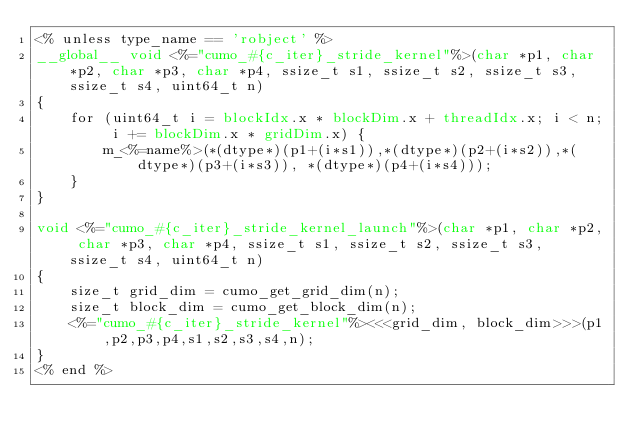Convert code to text. <code><loc_0><loc_0><loc_500><loc_500><_Cuda_><% unless type_name == 'robject' %>
__global__ void <%="cumo_#{c_iter}_stride_kernel"%>(char *p1, char *p2, char *p3, char *p4, ssize_t s1, ssize_t s2, ssize_t s3, ssize_t s4, uint64_t n)
{
    for (uint64_t i = blockIdx.x * blockDim.x + threadIdx.x; i < n; i += blockDim.x * gridDim.x) {
        m_<%=name%>(*(dtype*)(p1+(i*s1)),*(dtype*)(p2+(i*s2)),*(dtype*)(p3+(i*s3)), *(dtype*)(p4+(i*s4)));
    }
}

void <%="cumo_#{c_iter}_stride_kernel_launch"%>(char *p1, char *p2, char *p3, char *p4, ssize_t s1, ssize_t s2, ssize_t s3, ssize_t s4, uint64_t n)
{
    size_t grid_dim = cumo_get_grid_dim(n);
    size_t block_dim = cumo_get_block_dim(n);
    <%="cumo_#{c_iter}_stride_kernel"%><<<grid_dim, block_dim>>>(p1,p2,p3,p4,s1,s2,s3,s4,n);
}
<% end %>
</code> 